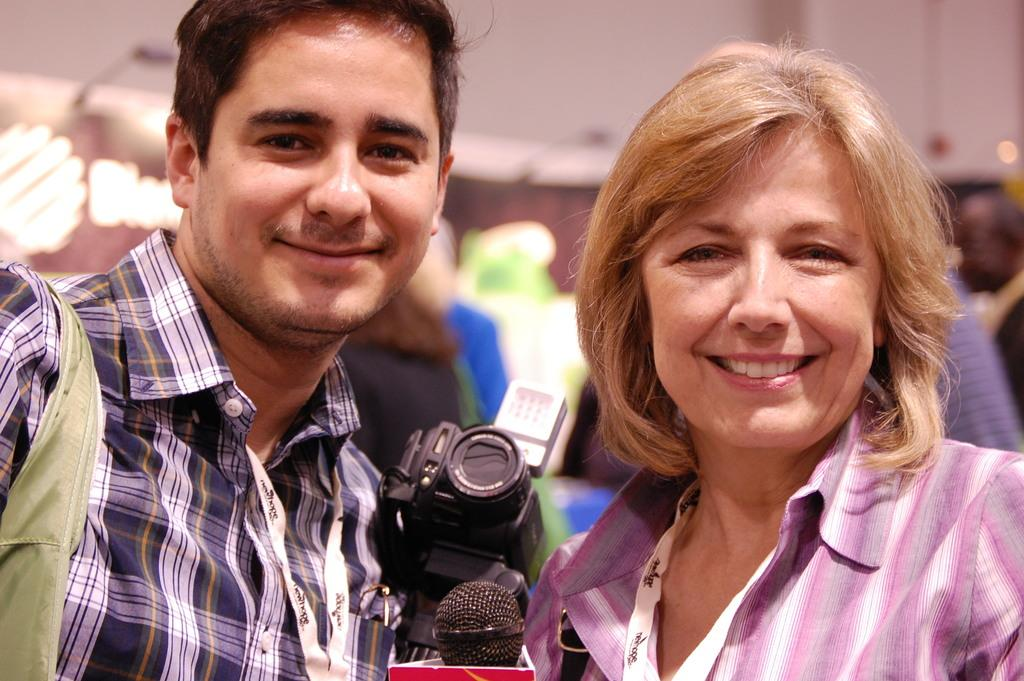How many people are present in the image? There is a man and a woman in the image, along with a few other people. What are the man and woman doing in the image? The man and woman are posing for a camera and smiling. What objects can be seen in the image related to photography? There is a camera and a microphone (mike) in the image. Can you describe the background of the image? The background of the image is blurred. What is the name of the silver sign visible in the image? There is no silver sign present in the image. What type of silverware can be seen in the hands of the man and woman? There is no silverware visible in the image; the man and woman are holding nothing in their hands. 